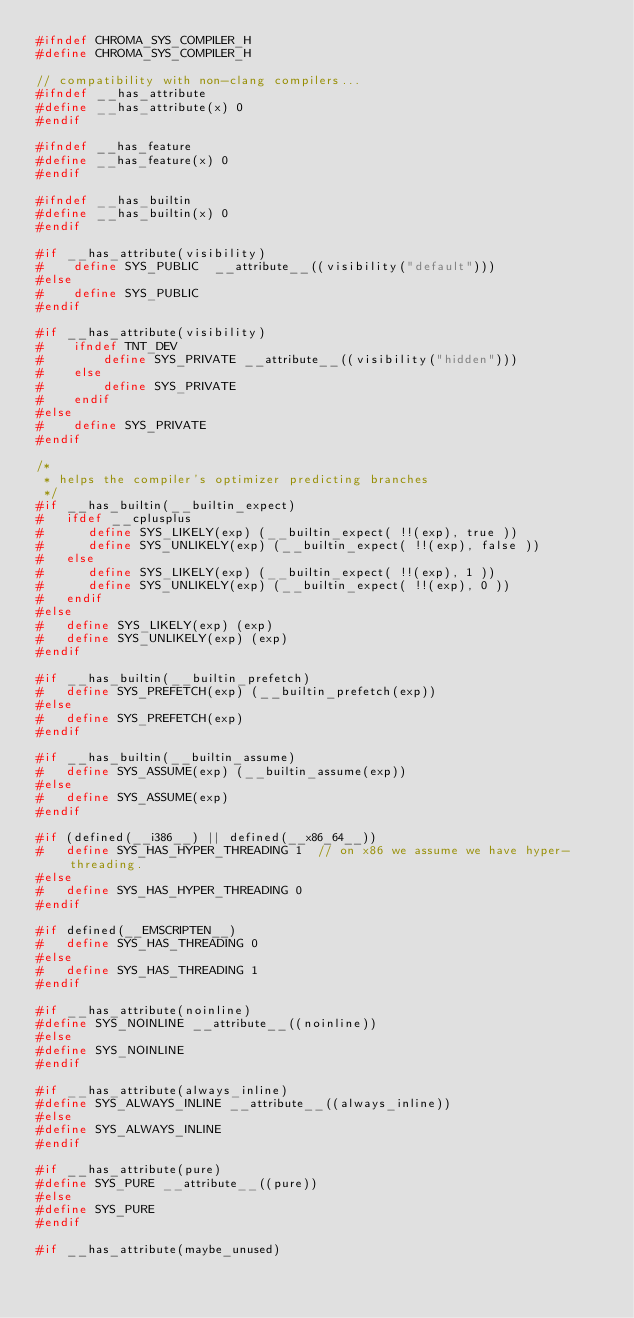<code> <loc_0><loc_0><loc_500><loc_500><_C_>#ifndef CHROMA_SYS_COMPILER_H
#define CHROMA_SYS_COMPILER_H

// compatibility with non-clang compilers...
#ifndef __has_attribute
#define __has_attribute(x) 0
#endif

#ifndef __has_feature
#define __has_feature(x) 0
#endif

#ifndef __has_builtin
#define __has_builtin(x) 0
#endif

#if __has_attribute(visibility)
#    define SYS_PUBLIC  __attribute__((visibility("default")))
#else
#    define SYS_PUBLIC  
#endif

#if __has_attribute(visibility)
#    ifndef TNT_DEV
#        define SYS_PRIVATE __attribute__((visibility("hidden")))
#    else
#        define SYS_PRIVATE
#    endif
#else
#    define SYS_PRIVATE
#endif

/*
 * helps the compiler's optimizer predicting branches
 */
#if __has_builtin(__builtin_expect)
#   ifdef __cplusplus
#      define SYS_LIKELY(exp) (__builtin_expect( !!(exp), true ))
#      define SYS_UNLIKELY(exp) (__builtin_expect( !!(exp), false ))
#   else
#      define SYS_LIKELY(exp) (__builtin_expect( !!(exp), 1 ))
#      define SYS_UNLIKELY(exp) (__builtin_expect( !!(exp), 0 ))
#   endif
#else
#   define SYS_LIKELY(exp) (exp)
#   define SYS_UNLIKELY(exp) (exp)
#endif

#if __has_builtin(__builtin_prefetch)
#   define SYS_PREFETCH(exp) (__builtin_prefetch(exp))
#else
#   define SYS_PREFETCH(exp)
#endif

#if __has_builtin(__builtin_assume)
#   define SYS_ASSUME(exp) (__builtin_assume(exp))
#else
#   define SYS_ASSUME(exp)
#endif

#if (defined(__i386__) || defined(__x86_64__))
#   define SYS_HAS_HYPER_THREADING 1  // on x86 we assume we have hyper-threading.
#else
#   define SYS_HAS_HYPER_THREADING 0
#endif

#if defined(__EMSCRIPTEN__)
#   define SYS_HAS_THREADING 0
#else
#   define SYS_HAS_THREADING 1
#endif

#if __has_attribute(noinline)
#define SYS_NOINLINE __attribute__((noinline))
#else
#define SYS_NOINLINE
#endif

#if __has_attribute(always_inline)
#define SYS_ALWAYS_INLINE __attribute__((always_inline))
#else
#define SYS_ALWAYS_INLINE
#endif

#if __has_attribute(pure)
#define SYS_PURE __attribute__((pure))
#else
#define SYS_PURE
#endif

#if __has_attribute(maybe_unused)</code> 